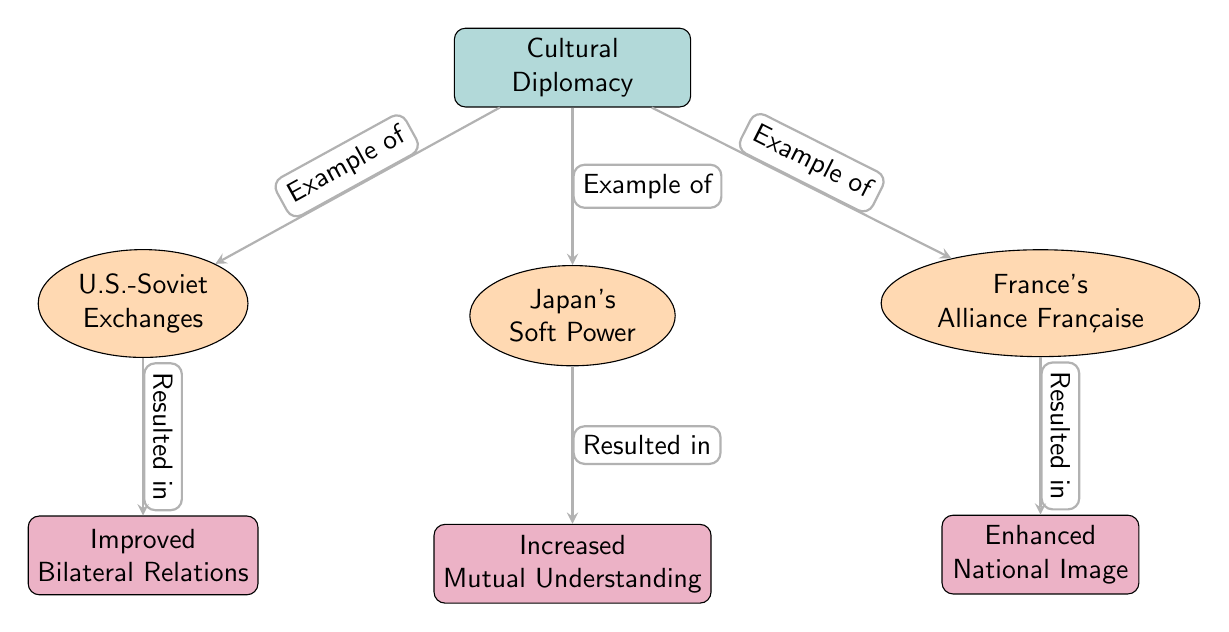What is the main node in this diagram? The main node is labeled "Cultural Diplomacy," located at the center of the diagram, indicating the primary subject being discussed.
Answer: Cultural Diplomacy How many case studies are presented in the diagram? There are three case studies illustrated, identified as "U.S.-Soviet Exchanges," "Japan's Soft Power," and "France's Alliance Française," which are positioned as nodes below the main node.
Answer: 3 What effect is linked to "U.S.-Soviet Exchanges"? The effect linked to "U.S.-Soviet Exchanges" is "Improved Bilateral Relations," which is shown directly below this case study in the diagram.
Answer: Improved Bilateral Relations Which case study leads to an effect of "Increased Mutual Understanding"? The case study that leads to "Increased Mutual Understanding" is "Japan's Soft Power," which points to this effect further down in the diagram.
Answer: Japan's Soft Power What type of node is "France's Alliance Française"? "France's Alliance Française" is categorized as a case study node, indicated by its ellipse shape and orange fill, differentiating it from other node types in the diagram.
Answer: Case study What is the relationship between "Cultural Diplomacy" and "France's Alliance Française"? The relationship is defined by an arrow labeled "Example of," which illustrates that "France's Alliance Française" acts as an example of cultural diplomacy, as displayed in the diagram.
Answer: Example of Which effect results from "France's Alliance Française"? The effect that results from "France's Alliance Française" is "Enhanced National Image," as shown in the diagram.
Answer: Enhanced National Image Which case study has a resulted effect described as "Resulted in"? Both "U.S.-Soviet Exchanges" and "Japan's Soft Power" have resulted effects described as "Resulted in," indicating multiple paths leading from these studies to their respective effects.
Answer: U.S.-Soviet Exchanges and Japan's Soft Power What is the color used for the effect nodes in the diagram? The effect nodes are colored purple, distinguishing them visually from both the case study nodes and the main node in the diagram.
Answer: Purple 